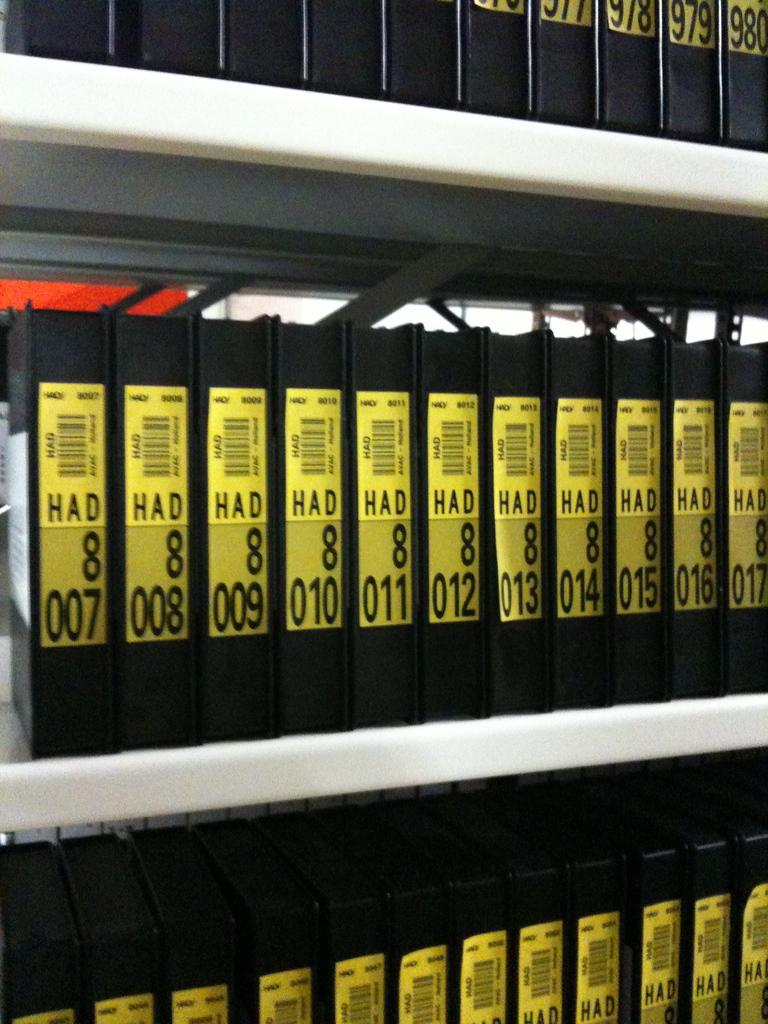<image>
Create a compact narrative representing the image presented. Shelves lined with books numbered in consecutive order. 